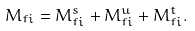<formula> <loc_0><loc_0><loc_500><loc_500>M _ { f i } = M ^ { s } _ { f i } + M ^ { u } _ { f i } + M ^ { t } _ { f i } .</formula> 